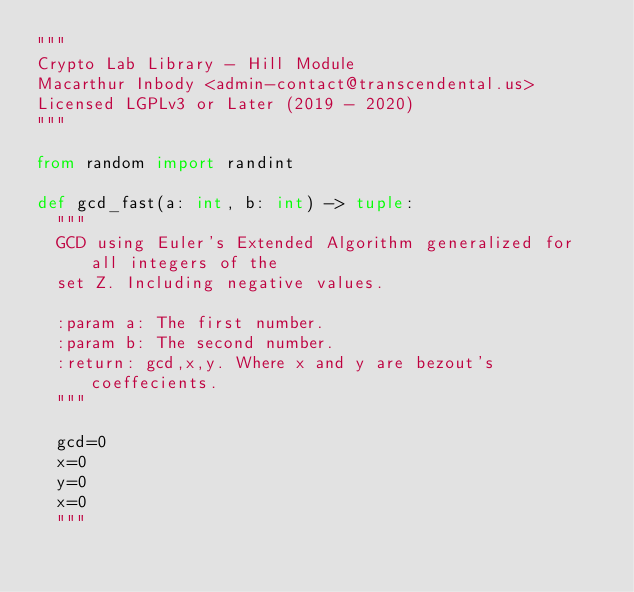Convert code to text. <code><loc_0><loc_0><loc_500><loc_500><_Python_>"""
Crypto Lab Library - Hill Module
Macarthur Inbody <admin-contact@transcendental.us>
Licensed LGPLv3 or Later (2019 - 2020)
"""

from random import randint

def gcd_fast(a: int, b: int) -> tuple:
	"""
	GCD using Euler's Extended Algorithm generalized for all integers of the
	set Z. Including negative values.

	:param a: The first number.
	:param b: The second number.
	:return: gcd,x,y. Where x and y are bezout's coeffecients.
	"""

	gcd=0
	x=0
	y=0
	x=0
	"""</code> 